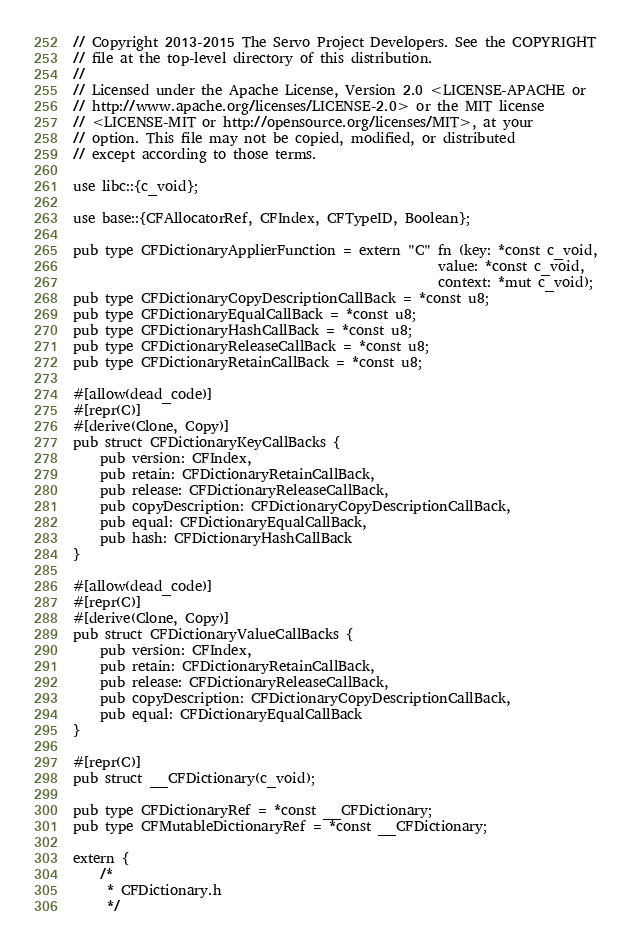Convert code to text. <code><loc_0><loc_0><loc_500><loc_500><_Rust_>// Copyright 2013-2015 The Servo Project Developers. See the COPYRIGHT
// file at the top-level directory of this distribution.
//
// Licensed under the Apache License, Version 2.0 <LICENSE-APACHE or
// http://www.apache.org/licenses/LICENSE-2.0> or the MIT license
// <LICENSE-MIT or http://opensource.org/licenses/MIT>, at your
// option. This file may not be copied, modified, or distributed
// except according to those terms.

use libc::{c_void};

use base::{CFAllocatorRef, CFIndex, CFTypeID, Boolean};

pub type CFDictionaryApplierFunction = extern "C" fn (key: *const c_void,
                                                      value: *const c_void,
                                                      context: *mut c_void);
pub type CFDictionaryCopyDescriptionCallBack = *const u8;
pub type CFDictionaryEqualCallBack = *const u8;
pub type CFDictionaryHashCallBack = *const u8;
pub type CFDictionaryReleaseCallBack = *const u8;
pub type CFDictionaryRetainCallBack = *const u8;

#[allow(dead_code)]
#[repr(C)]
#[derive(Clone, Copy)]
pub struct CFDictionaryKeyCallBacks {
    pub version: CFIndex,
    pub retain: CFDictionaryRetainCallBack,
    pub release: CFDictionaryReleaseCallBack,
    pub copyDescription: CFDictionaryCopyDescriptionCallBack,
    pub equal: CFDictionaryEqualCallBack,
    pub hash: CFDictionaryHashCallBack
}

#[allow(dead_code)]
#[repr(C)]
#[derive(Clone, Copy)]
pub struct CFDictionaryValueCallBacks {
    pub version: CFIndex,
    pub retain: CFDictionaryRetainCallBack,
    pub release: CFDictionaryReleaseCallBack,
    pub copyDescription: CFDictionaryCopyDescriptionCallBack,
    pub equal: CFDictionaryEqualCallBack
}

#[repr(C)]
pub struct __CFDictionary(c_void);

pub type CFDictionaryRef = *const __CFDictionary;
pub type CFMutableDictionaryRef = *const __CFDictionary;

extern {
    /*
     * CFDictionary.h
     */
</code> 